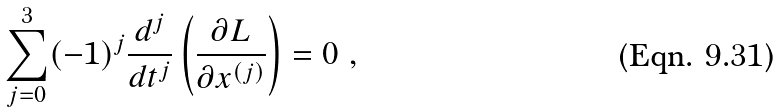Convert formula to latex. <formula><loc_0><loc_0><loc_500><loc_500>\sum _ { j = 0 } ^ { 3 } ( - 1 ) ^ { j } \frac { d ^ { j } } { d t ^ { j } } \left ( \frac { \partial { L } } { \partial { x ^ { ( j ) } } } \right ) = 0 \ ,</formula> 